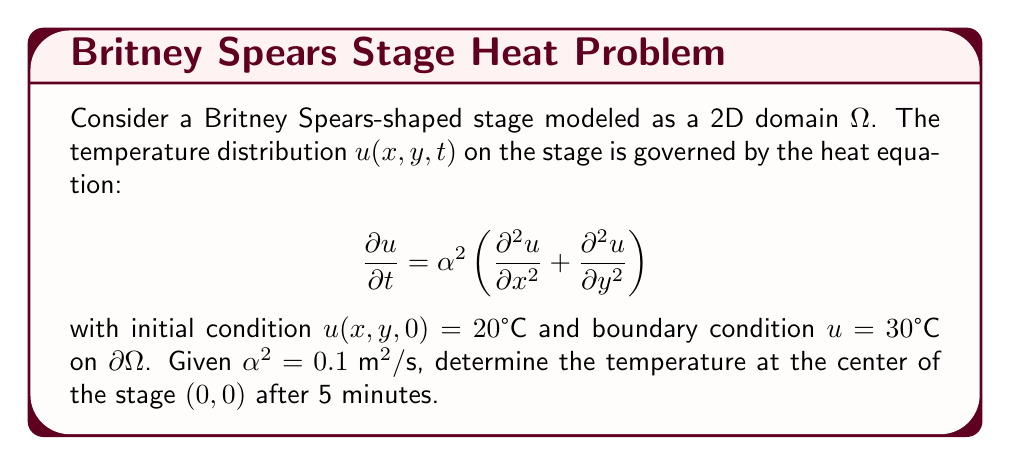Solve this math problem. To solve this problem, we need to use the solution to the 2D heat equation on a finite domain. The general solution is given by:

$$u(x,y,t) = \sum_{m=1}^{\infty}\sum_{n=1}^{\infty} A_{mn} \sin(\frac{m\pi x}{L_x}) \sin(\frac{n\pi y}{L_y}) e^{-\alpha^2(\frac{m^2\pi^2}{L_x^2}+\frac{n^2\pi^2}{L_y^2})t}$$

Where $L_x$ and $L_y$ are the dimensions of the stage, and $A_{mn}$ are coefficients determined by the initial conditions.

For our Britney-shaped stage, we'll approximate it as a square with side length L = 10 m. The center is at (0, 0).

1) The steady-state solution (as t → ∞) is 30°C due to the boundary condition.

2) The transient part of the solution is:

   $$u_t(x,y,t) = \sum_{m=1}^{\infty}\sum_{n=1}^{\infty} A_{mn} \sin(\frac{m\pi x}{L}) \sin(\frac{n\pi y}{L}) e^{-\alpha^2(\frac{m^2+n^2}{L^2})\pi^2t}$$

3) At the center (0, 0), all terms with even m or n vanish, so we only need odd terms:

   $$u_t(0,0,t) = \sum_{m,n\text{ odd}} A_{mn} e^{-\alpha^2(\frac{m^2+n^2}{L^2})\pi^2t}$$

4) The largest term is when m = n = 1, which dominates the solution:

   $$u_t(0,0,t) \approx A_{11} e^{-2\alpha^2(\frac{\pi}{L})^2t}$$

5) $A_{11}$ can be approximated as $\frac{16}{\pi^2}(u_0 - u_\infty) = \frac{16}{\pi^2}(20 - 30) = -\frac{160}{\pi^2}$

6) Substituting the values (α² = 0.1 m²/s, L = 10 m, t = 5 * 60 = 300 s):

   $$u_t(0,0,300) \approx -\frac{160}{\pi^2} e^{-2(0.1)(\frac{\pi}{10})^2(300)} \approx -9.77°C$$

7) The final temperature is the sum of the steady-state and transient parts:

   $$u(0,0,300) = 30°C + (-9.77°C) = 20.23°C$$
Answer: 20.23°C 